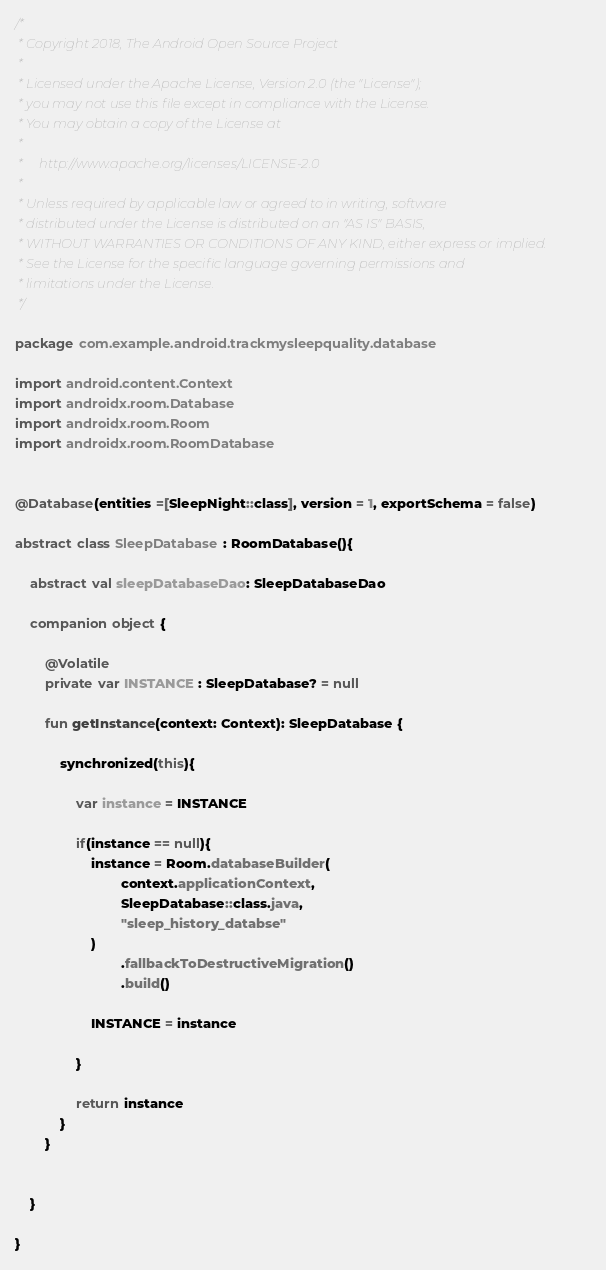Convert code to text. <code><loc_0><loc_0><loc_500><loc_500><_Kotlin_>/*
 * Copyright 2018, The Android Open Source Project
 *
 * Licensed under the Apache License, Version 2.0 (the "License");
 * you may not use this file except in compliance with the License.
 * You may obtain a copy of the License at
 *
 *     http://www.apache.org/licenses/LICENSE-2.0
 *
 * Unless required by applicable law or agreed to in writing, software
 * distributed under the License is distributed on an "AS IS" BASIS,
 * WITHOUT WARRANTIES OR CONDITIONS OF ANY KIND, either express or implied.
 * See the License for the specific language governing permissions and
 * limitations under the License.
 */

package com.example.android.trackmysleepquality.database

import android.content.Context
import androidx.room.Database
import androidx.room.Room
import androidx.room.RoomDatabase


@Database(entities =[SleepNight::class], version = 1, exportSchema = false)

abstract class SleepDatabase : RoomDatabase(){

    abstract val sleepDatabaseDao: SleepDatabaseDao

    companion object {

        @Volatile
        private var INSTANCE : SleepDatabase? = null

        fun getInstance(context: Context): SleepDatabase {

            synchronized(this){

                var instance = INSTANCE

                if(instance == null){
                    instance = Room.databaseBuilder(
                            context.applicationContext,
                            SleepDatabase::class.java,
                            "sleep_history_databse"
                    )
                            .fallbackToDestructiveMigration()
                            .build()

                    INSTANCE = instance

                }

                return instance
            }
        }


    }

}
</code> 